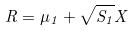<formula> <loc_0><loc_0><loc_500><loc_500>R = \mu _ { 1 } + \sqrt { S _ { 1 } } X</formula> 